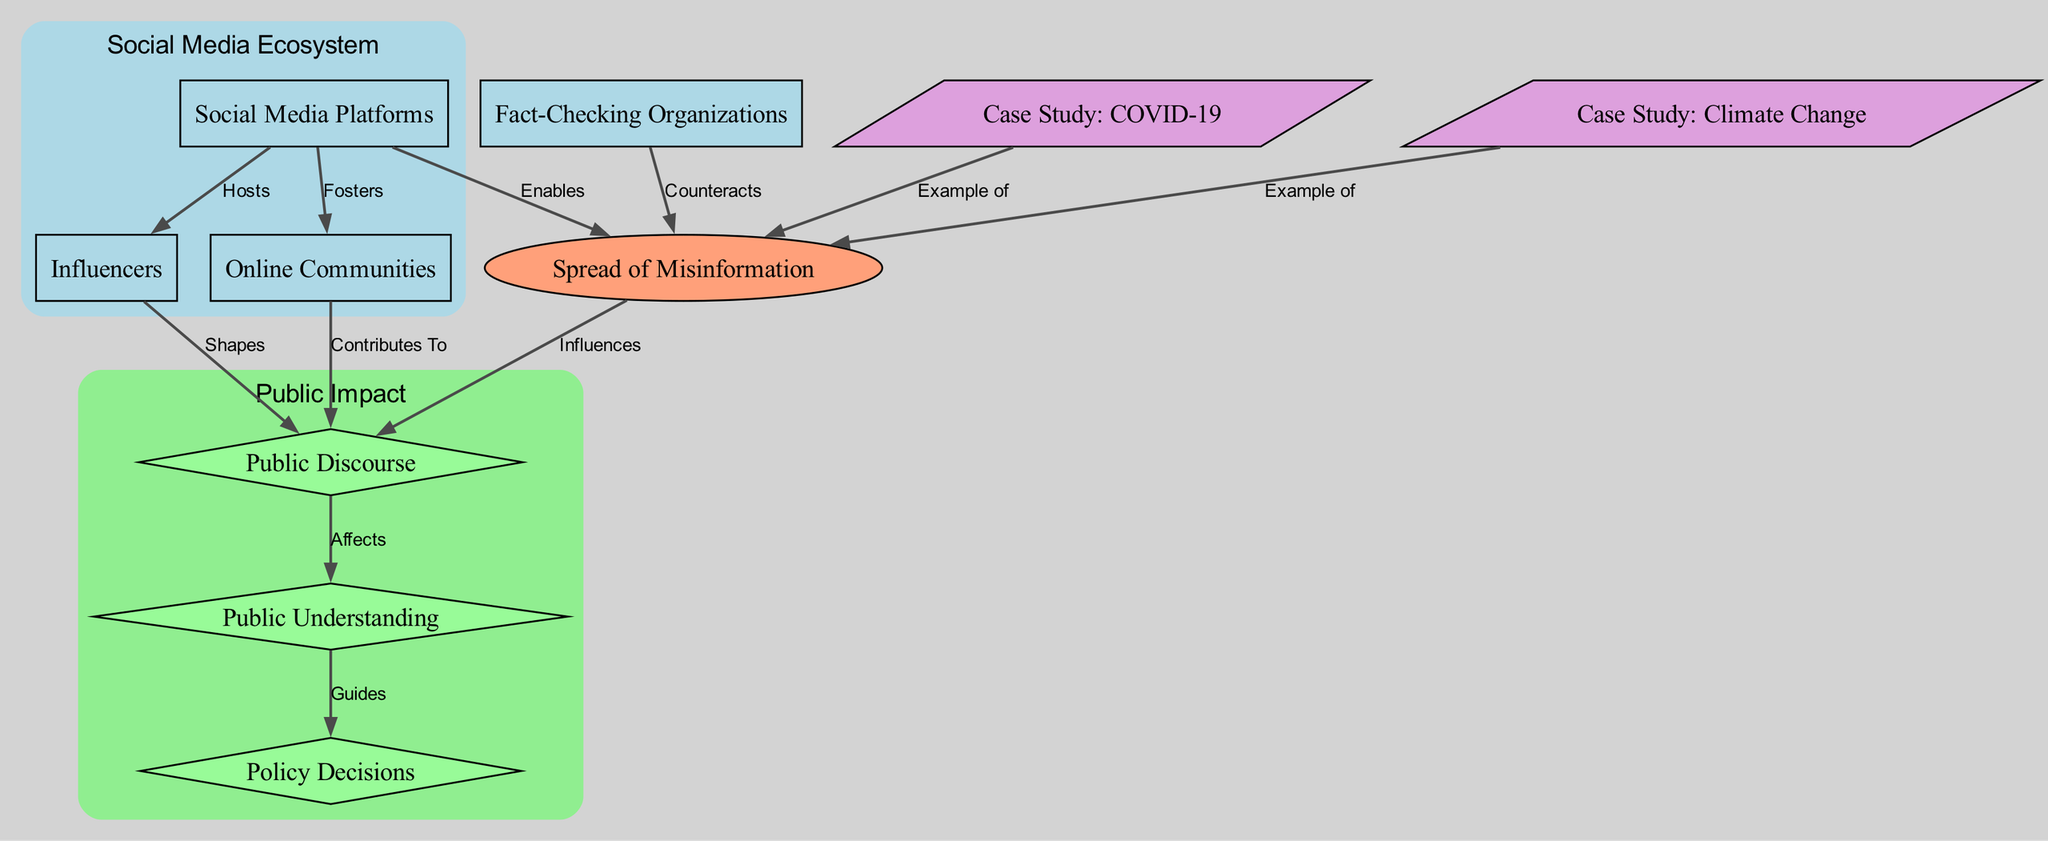What are the three main types of nodes in the diagram? The diagram includes three main types of nodes: entities, factors, and outcomes. Entities represent people or groups, factors are influences or specific conditions, and outcomes show the results of the relationships.
Answer: entities, factors, outcomes How many nodes are present in the diagram? By counting each node listed in the data, we find that there are a total of 10 nodes represented in the diagram.
Answer: 10 What relationship does "Social Media Platforms" have with "Spread of Misinformation"? The relationship between "Social Media Platforms" and "Spread of Misinformation" is labeled as "Enables," indicating that social media platforms facilitate the spread of misinformation.
Answer: Enables Which node contributes to "Public Discourse"? The node "Online Communities" has a relationship labeled "Contributes To" with "Public Discourse," meaning it plays a role in shaping public discussions on scientific topics.
Answer: Online Communities How do "Fact-Checking Organizations" interact with "Spread of Misinformation"? "Fact-Checking Organizations" have a relationship with "Spread of Misinformation" that is labeled "Counteracts," indicating that they work to reduce or mitigate the spread of misinformation.
Answer: Counteracts What single outcome is guided by "Public Understanding"? The outcome that is guided by "Public Understanding" is "Policy Decisions," which means that understanding the public has a significant impact on the decisions made in policy areas.
Answer: Policy Decisions In what way do influencers affect "Public Discourse"? "Influencers" have a defined relationship with "Public Discourse," labeled as "Shapes," indicating that their opinions and actions meaningfully shape how the public discusses scientific matters.
Answer: Shapes What do the case studies "COVID-19" and "Climate Change" exemplify in the diagram? Both case studies are connected to "Spread of Misinformation" with a relationship labeled "Example of," demonstrating that they represent notable instances of misinformation in the context of these subjects.
Answer: Example of Which relationship illustrates a negative influence on public discourse? The relationship "Spread of Misinformation" influencing "Public Discourse" represents a negative effect, implying that misinformation can distort public understanding and discussion.
Answer: Influences 